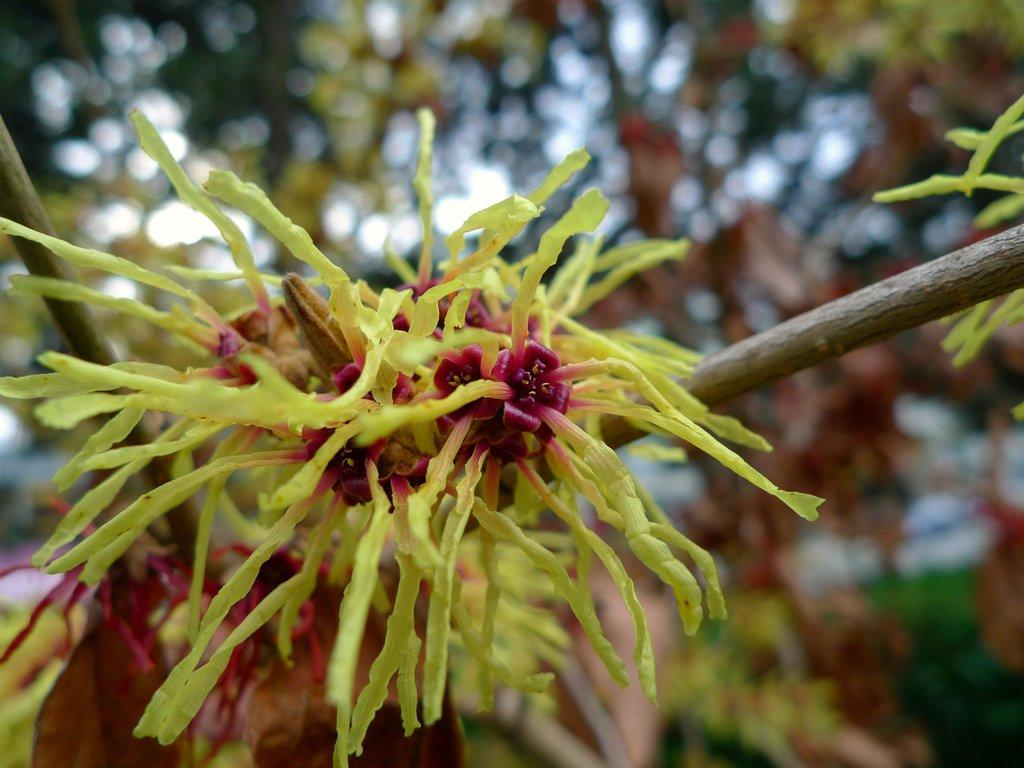What type of plant is present in the image? There is a witch hazel in the image. How many bikes are parked next to the witch hazel in the image? There are no bikes present in the image; it only features a witch hazel plant. What type of badge is the witch hazel wearing in the image? Witch hazel plants do not wear badges, as they are plants and not people or animals. 